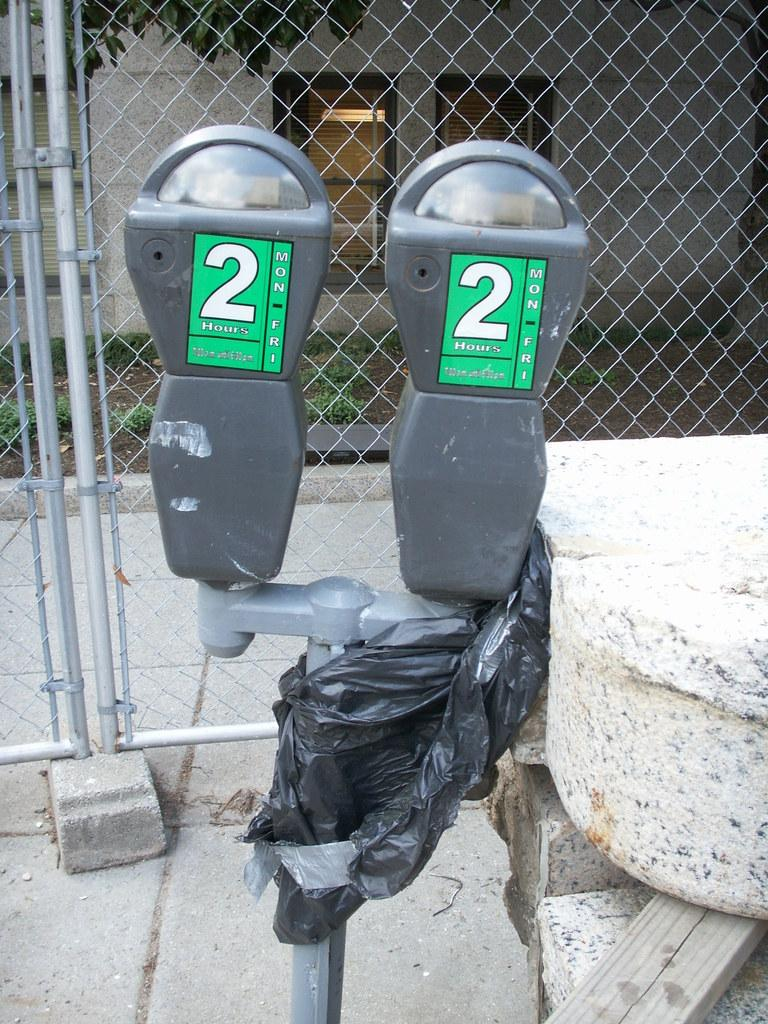<image>
Create a compact narrative representing the image presented. Two parking meters with "2 hours" written on them and a trash bag tied around it. 